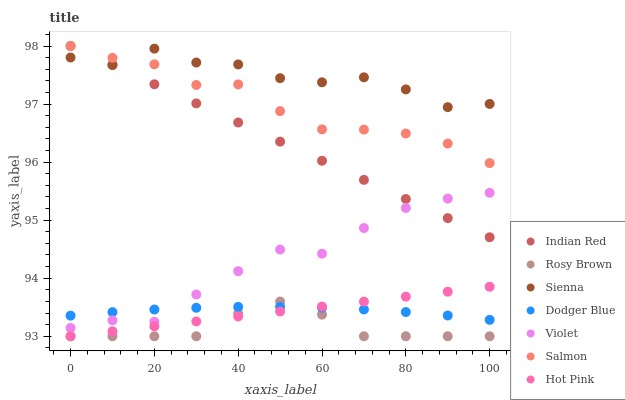Does Rosy Brown have the minimum area under the curve?
Answer yes or no. Yes. Does Sienna have the maximum area under the curve?
Answer yes or no. Yes. Does Salmon have the minimum area under the curve?
Answer yes or no. No. Does Salmon have the maximum area under the curve?
Answer yes or no. No. Is Hot Pink the smoothest?
Answer yes or no. Yes. Is Sienna the roughest?
Answer yes or no. Yes. Is Rosy Brown the smoothest?
Answer yes or no. No. Is Rosy Brown the roughest?
Answer yes or no. No. Does Hot Pink have the lowest value?
Answer yes or no. Yes. Does Salmon have the lowest value?
Answer yes or no. No. Does Indian Red have the highest value?
Answer yes or no. Yes. Does Rosy Brown have the highest value?
Answer yes or no. No. Is Hot Pink less than Salmon?
Answer yes or no. Yes. Is Indian Red greater than Rosy Brown?
Answer yes or no. Yes. Does Hot Pink intersect Rosy Brown?
Answer yes or no. Yes. Is Hot Pink less than Rosy Brown?
Answer yes or no. No. Is Hot Pink greater than Rosy Brown?
Answer yes or no. No. Does Hot Pink intersect Salmon?
Answer yes or no. No. 